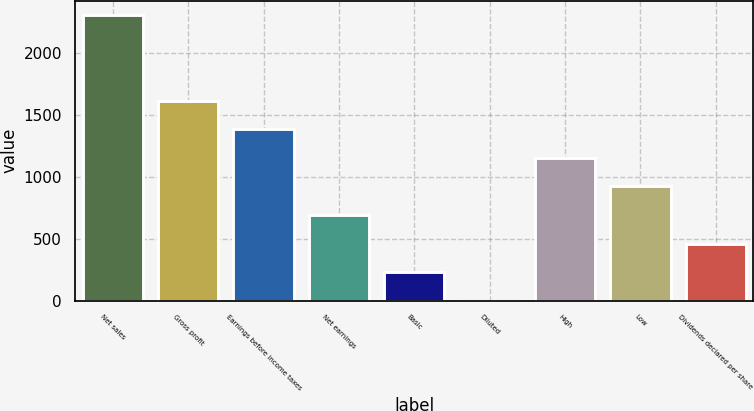<chart> <loc_0><loc_0><loc_500><loc_500><bar_chart><fcel>Net sales<fcel>Gross profit<fcel>Earnings before income taxes<fcel>Net earnings<fcel>Basic<fcel>Diluted<fcel>High<fcel>Low<fcel>Dividends declared per share<nl><fcel>2305<fcel>1613.54<fcel>1383.06<fcel>691.62<fcel>230.66<fcel>0.18<fcel>1152.58<fcel>922.1<fcel>461.14<nl></chart> 